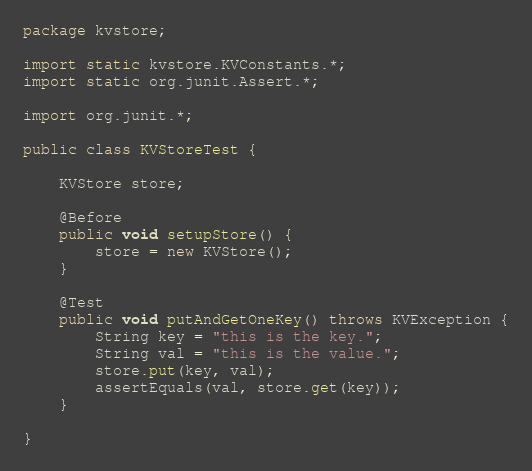Convert code to text. <code><loc_0><loc_0><loc_500><loc_500><_Java_>package kvstore;

import static kvstore.KVConstants.*;
import static org.junit.Assert.*;

import org.junit.*;

public class KVStoreTest {

    KVStore store;

    @Before
    public void setupStore() {
        store = new KVStore();
    }

    @Test
    public void putAndGetOneKey() throws KVException {
        String key = "this is the key.";
        String val = "this is the value.";
        store.put(key, val);
        assertEquals(val, store.get(key));
    }

}
</code> 